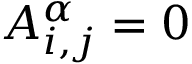<formula> <loc_0><loc_0><loc_500><loc_500>A _ { i , j } ^ { \alpha } = 0</formula> 